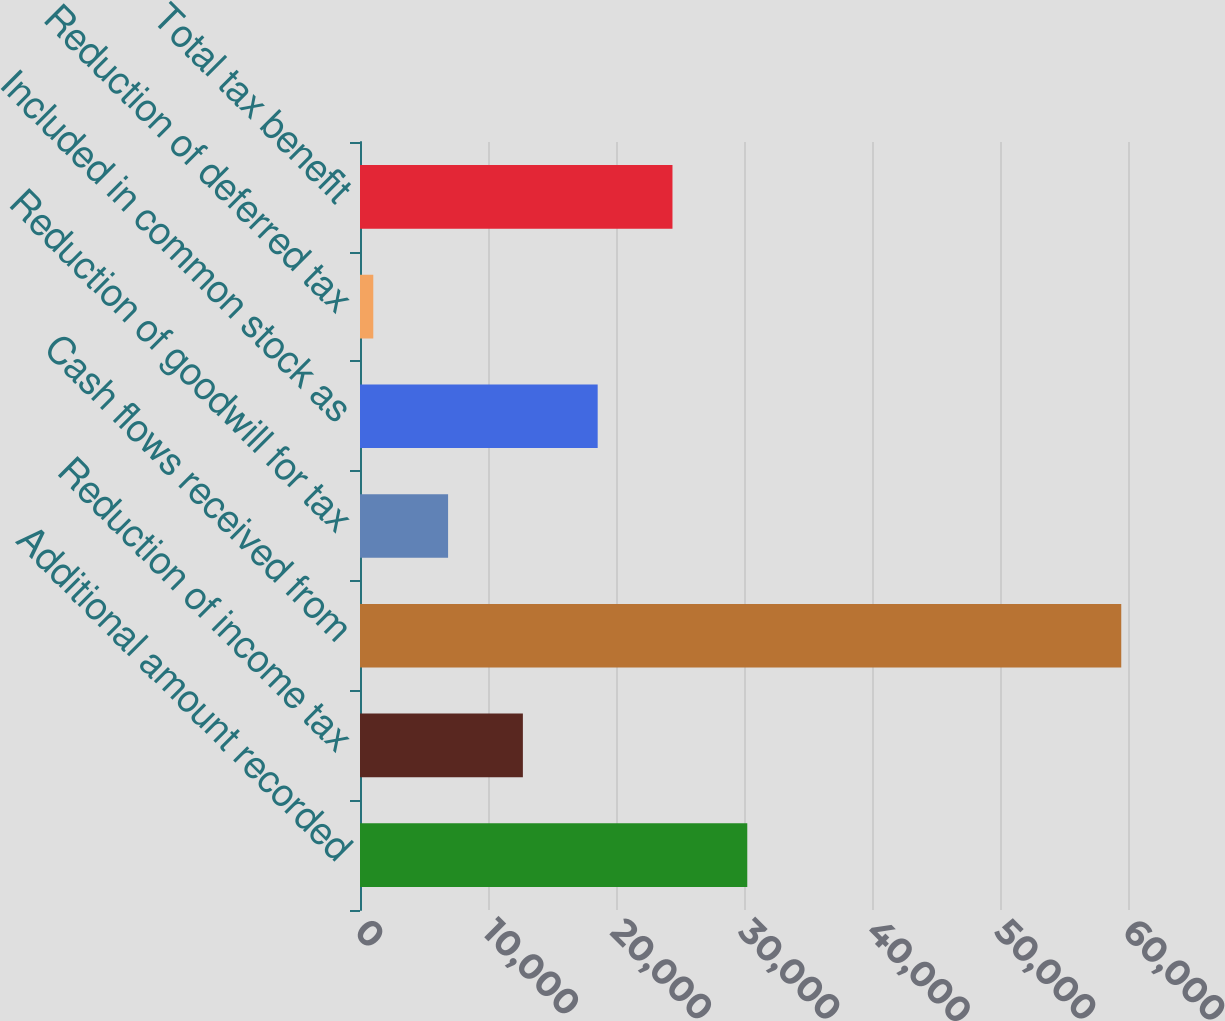<chart> <loc_0><loc_0><loc_500><loc_500><bar_chart><fcel>Additional amount recorded<fcel>Reduction of income tax<fcel>Cash flows received from<fcel>Reduction of goodwill for tax<fcel>Included in common stock as<fcel>Reduction of deferred tax<fcel>Total tax benefit<nl><fcel>30255.5<fcel>12725<fcel>59473<fcel>6881.5<fcel>18568.5<fcel>1038<fcel>24412<nl></chart> 